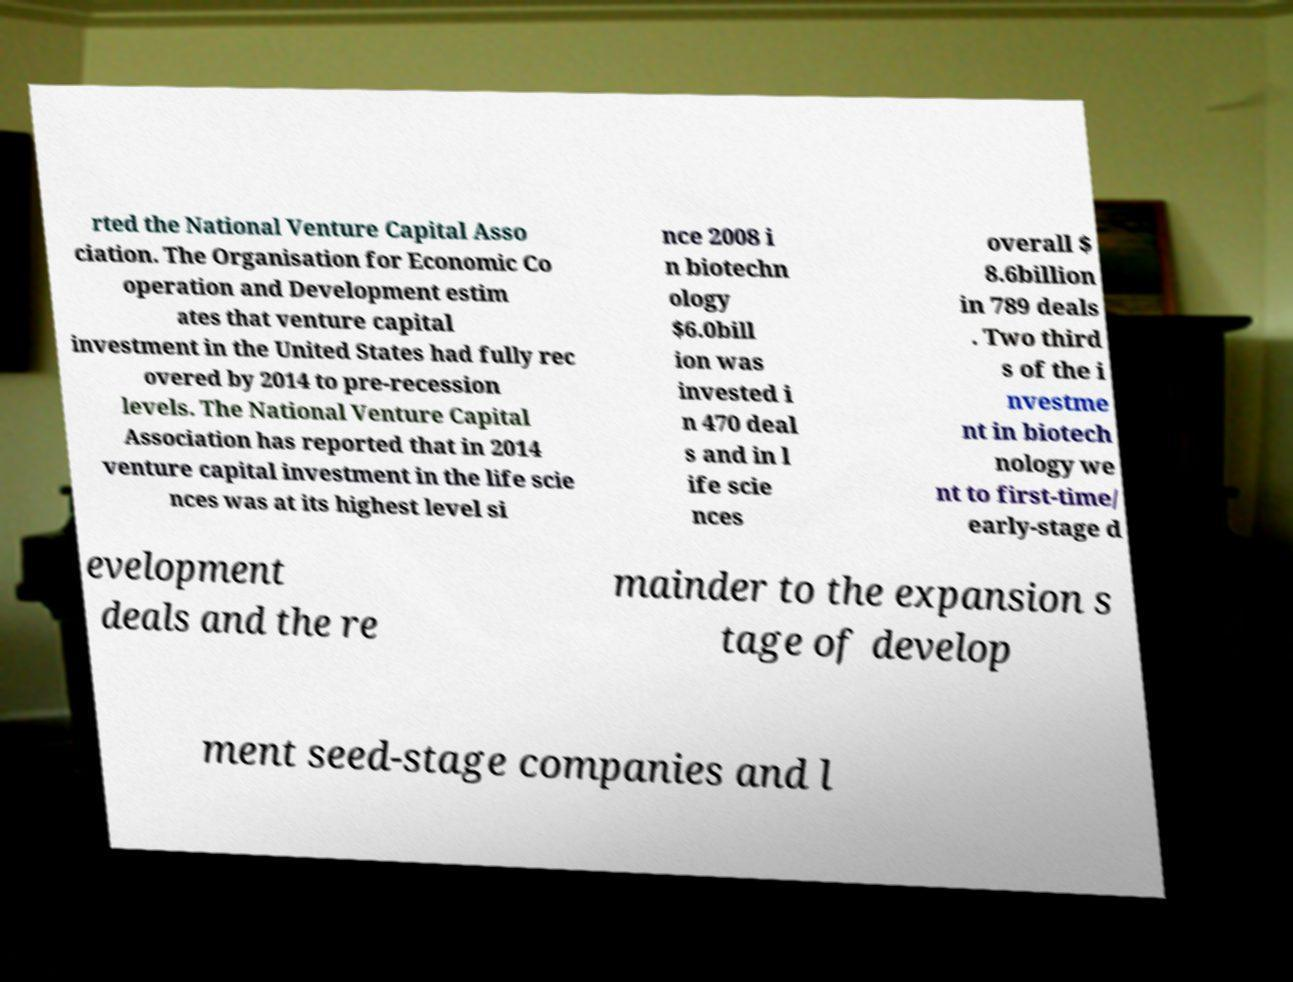I need the written content from this picture converted into text. Can you do that? rted the National Venture Capital Asso ciation. The Organisation for Economic Co operation and Development estim ates that venture capital investment in the United States had fully rec overed by 2014 to pre-recession levels. The National Venture Capital Association has reported that in 2014 venture capital investment in the life scie nces was at its highest level si nce 2008 i n biotechn ology $6.0bill ion was invested i n 470 deal s and in l ife scie nces overall $ 8.6billion in 789 deals . Two third s of the i nvestme nt in biotech nology we nt to first-time/ early-stage d evelopment deals and the re mainder to the expansion s tage of develop ment seed-stage companies and l 